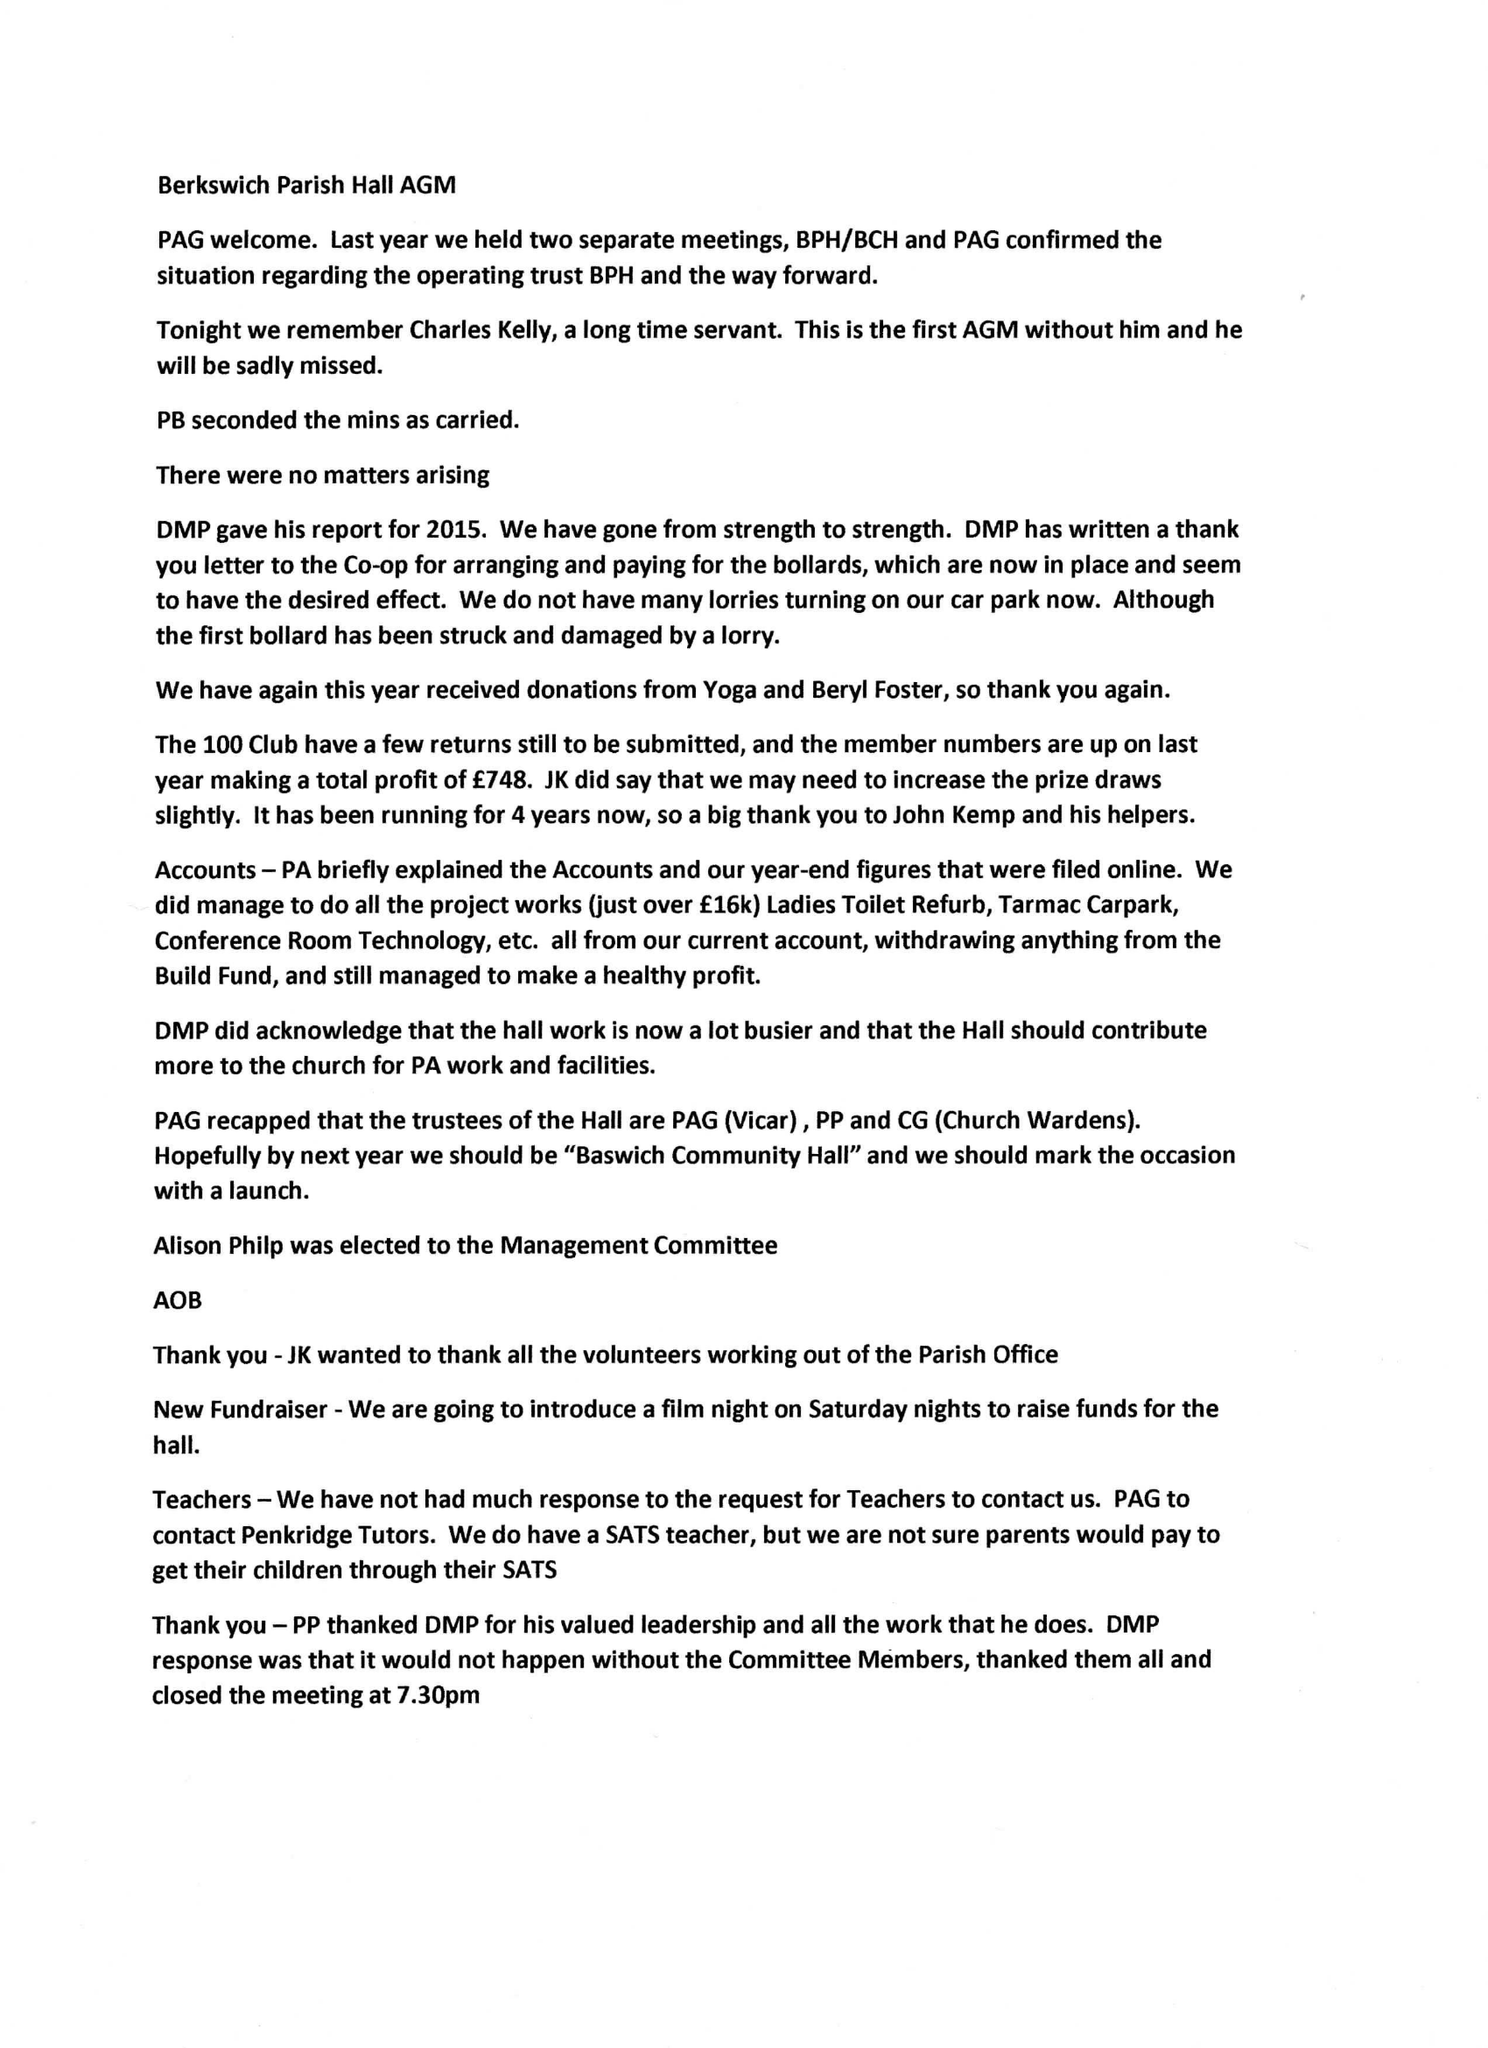What is the value for the income_annually_in_british_pounds?
Answer the question using a single word or phrase. 26296.00 